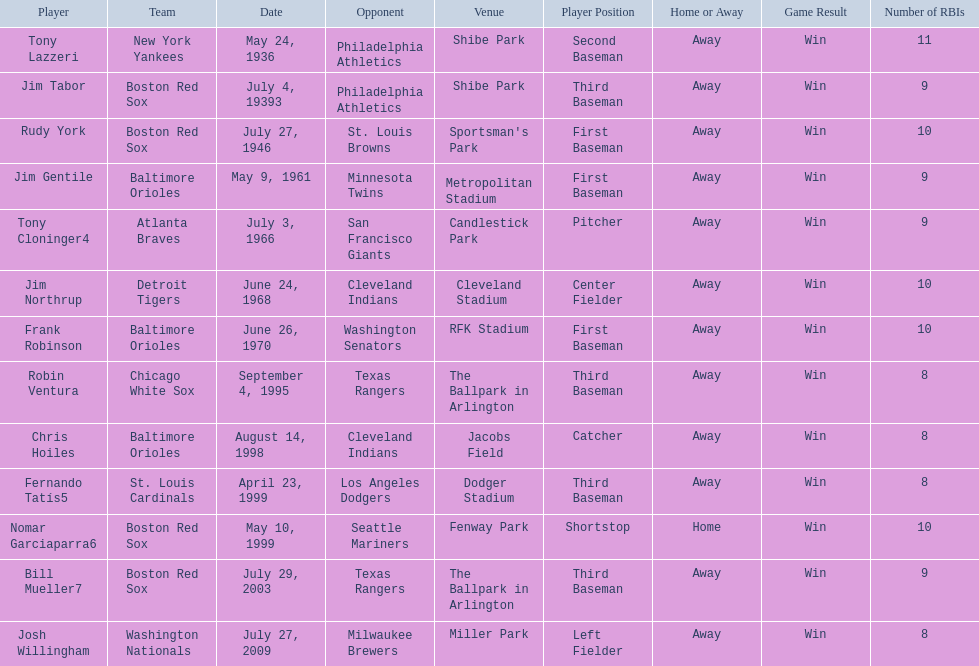Who are the opponents of the boston red sox during baseball home run records? Philadelphia Athletics, St. Louis Browns, Seattle Mariners, Texas Rangers. Of those which was the opponent on july 27, 1946? St. Louis Browns. 